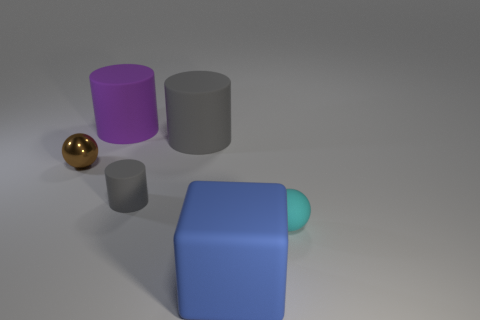Is there anything else that is the same material as the brown sphere?
Make the answer very short. No. What number of large purple cylinders are the same material as the brown ball?
Ensure brevity in your answer.  0. What material is the sphere that is left of the gray thing in front of the rubber cylinder right of the small gray cylinder?
Provide a short and direct response. Metal. What is the color of the small rubber object that is on the left side of the big blue rubber cube right of the small metal ball?
Give a very brief answer. Gray. The other sphere that is the same size as the metallic ball is what color?
Offer a very short reply. Cyan. What number of large things are either brown shiny spheres or cyan metal cylinders?
Offer a terse response. 0. Is the number of big blue objects that are behind the small brown metal thing greater than the number of small matte objects that are left of the block?
Your answer should be very brief. No. What number of other objects are the same size as the metallic thing?
Your answer should be compact. 2. Is the small ball that is left of the large cube made of the same material as the small cyan sphere?
Your answer should be very brief. No. How many other objects are there of the same color as the large matte cube?
Make the answer very short. 0. 